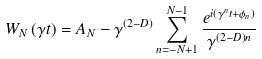<formula> <loc_0><loc_0><loc_500><loc_500>W _ { N } \left ( \gamma t \right ) = A _ { N } - \gamma ^ { \left ( 2 - D \right ) } \sum _ { n = - N + 1 } ^ { N - 1 } \frac { e ^ { i \left ( \gamma ^ { n } t + \phi _ { n } \right ) } } { \gamma ^ { \left ( 2 - D \right ) n } }</formula> 